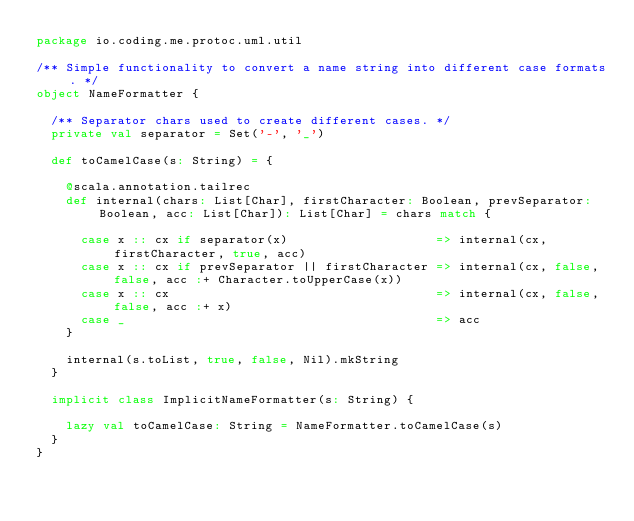<code> <loc_0><loc_0><loc_500><loc_500><_Scala_>package io.coding.me.protoc.uml.util

/** Simple functionality to convert a name string into different case formats. */
object NameFormatter {

  /** Separator chars used to create different cases. */
  private val separator = Set('-', '_')

  def toCamelCase(s: String) = {

    @scala.annotation.tailrec
    def internal(chars: List[Char], firstCharacter: Boolean, prevSeparator: Boolean, acc: List[Char]): List[Char] = chars match {

      case x :: cx if separator(x)                    => internal(cx, firstCharacter, true, acc)
      case x :: cx if prevSeparator || firstCharacter => internal(cx, false, false, acc :+ Character.toUpperCase(x))
      case x :: cx                                    => internal(cx, false, false, acc :+ x)
      case _                                          => acc
    }

    internal(s.toList, true, false, Nil).mkString
  }

  implicit class ImplicitNameFormatter(s: String) {

    lazy val toCamelCase: String = NameFormatter.toCamelCase(s)
  }
}
</code> 